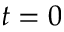Convert formula to latex. <formula><loc_0><loc_0><loc_500><loc_500>t = 0</formula> 